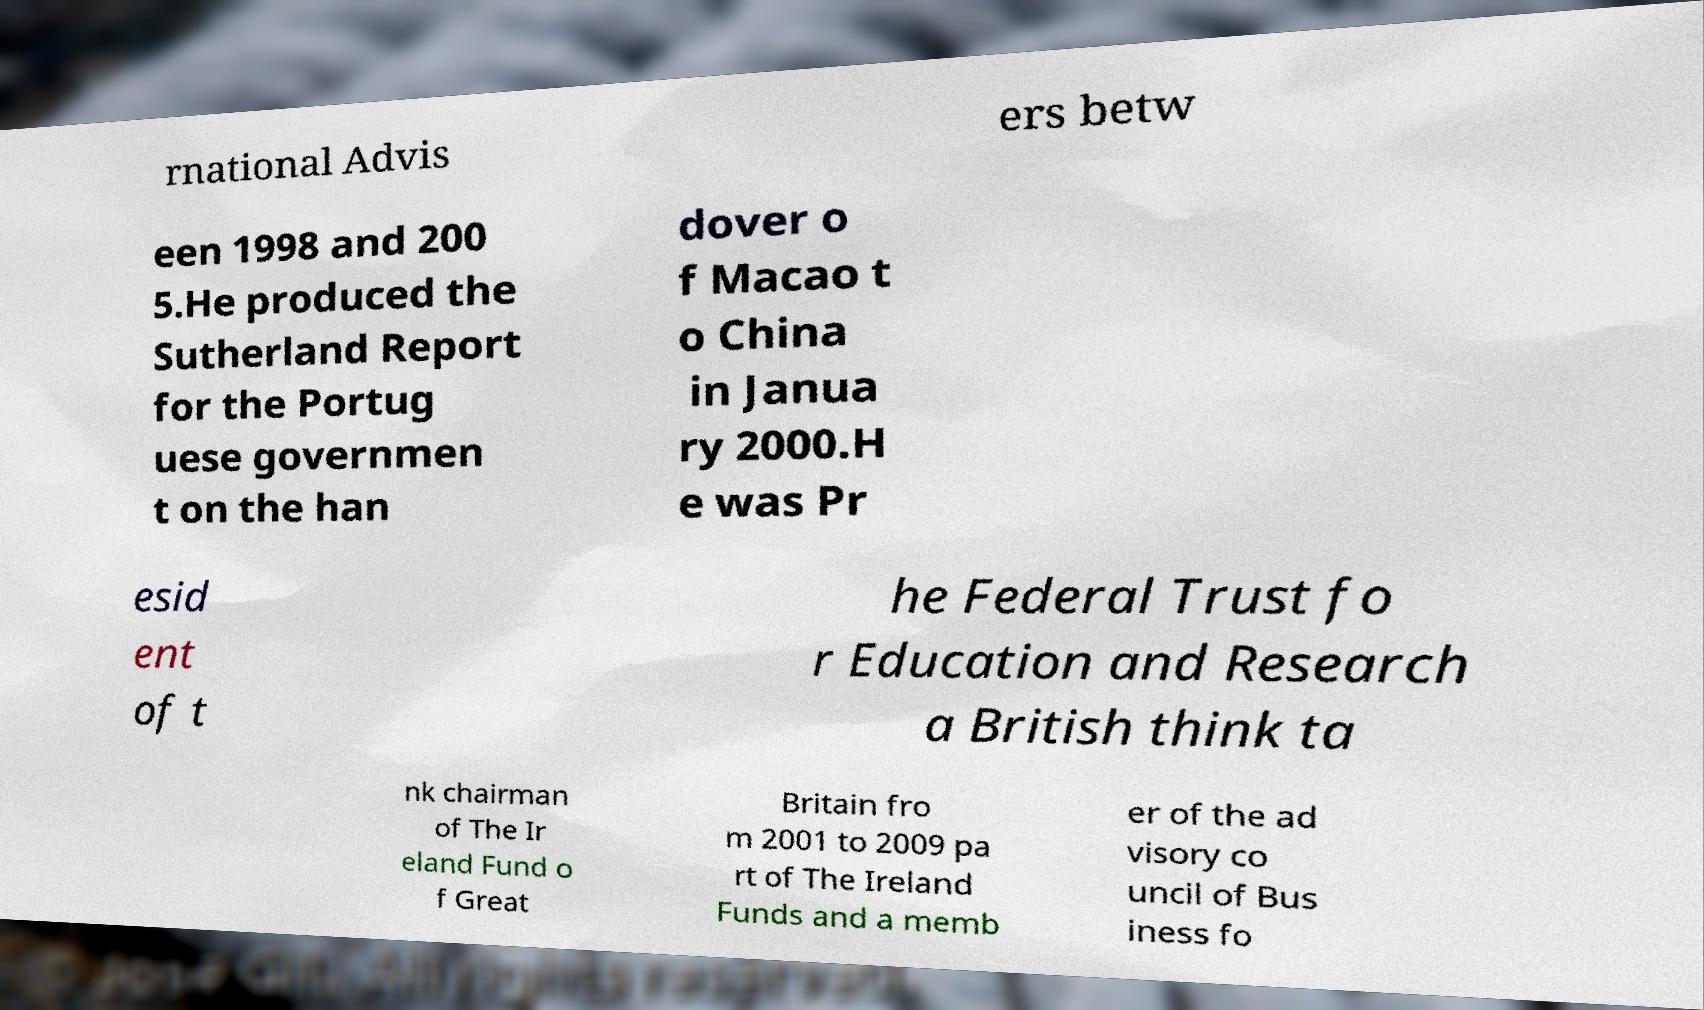I need the written content from this picture converted into text. Can you do that? rnational Advis ers betw een 1998 and 200 5.He produced the Sutherland Report for the Portug uese governmen t on the han dover o f Macao t o China in Janua ry 2000.H e was Pr esid ent of t he Federal Trust fo r Education and Research a British think ta nk chairman of The Ir eland Fund o f Great Britain fro m 2001 to 2009 pa rt of The Ireland Funds and a memb er of the ad visory co uncil of Bus iness fo 